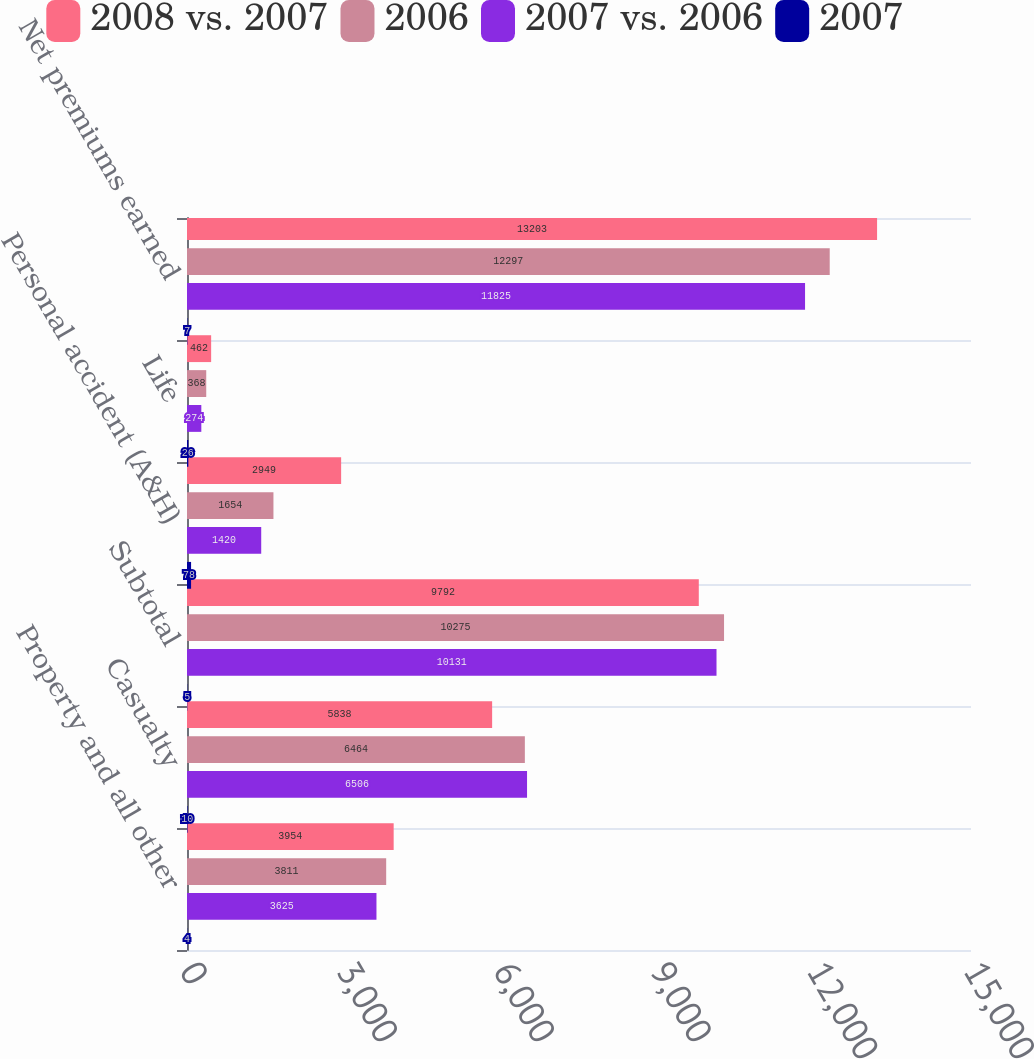Convert chart to OTSL. <chart><loc_0><loc_0><loc_500><loc_500><stacked_bar_chart><ecel><fcel>Property and all other<fcel>Casualty<fcel>Subtotal<fcel>Personal accident (A&H)<fcel>Life<fcel>Net premiums earned<nl><fcel>2008 vs. 2007<fcel>3954<fcel>5838<fcel>9792<fcel>2949<fcel>462<fcel>13203<nl><fcel>2006<fcel>3811<fcel>6464<fcel>10275<fcel>1654<fcel>368<fcel>12297<nl><fcel>2007 vs. 2006<fcel>3625<fcel>6506<fcel>10131<fcel>1420<fcel>274<fcel>11825<nl><fcel>2007<fcel>4<fcel>10<fcel>5<fcel>78<fcel>26<fcel>7<nl></chart> 